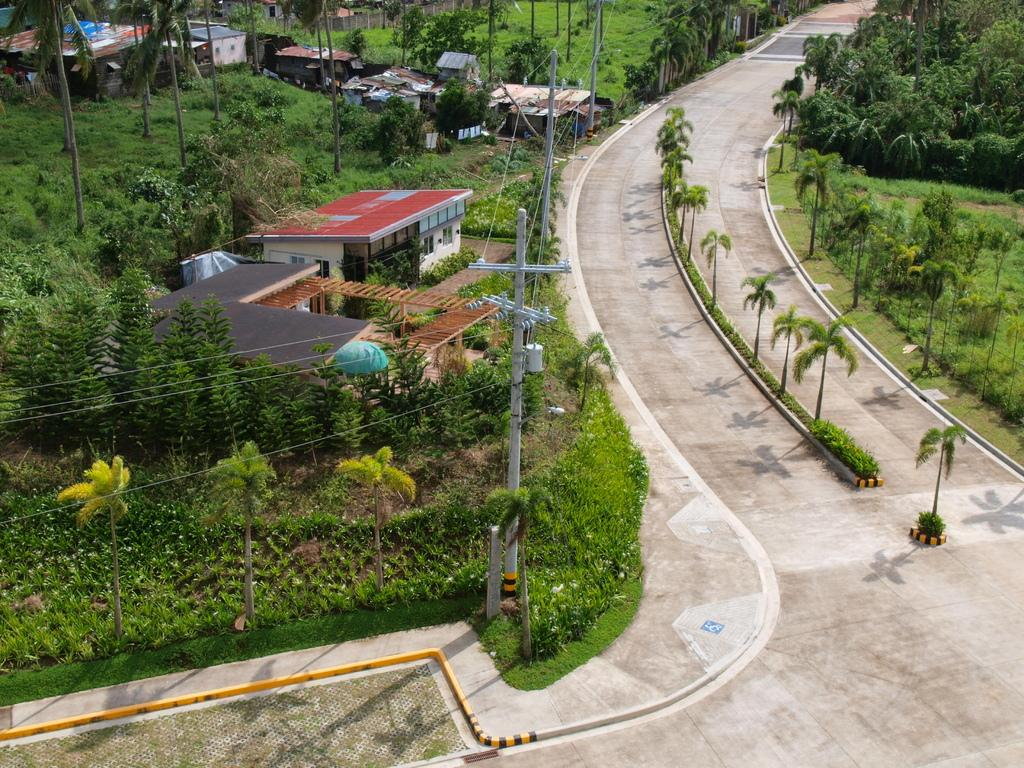What type of view is depicted in the image? The image shows an aerial view. What type of vegetation can be seen in the image? There is a tree, plants, and grass visible in the image. What type of structures are present in the image? There are houses in the image. What type of transportation infrastructure can be seen in the image? There is a road visible in the image. What type of blade is being used to cut the grass in the image? There is no blade visible in the image, as the grass appears to be natural and not cut. What type of building is visible in the image? There are no buildings visible in the image, only houses. 